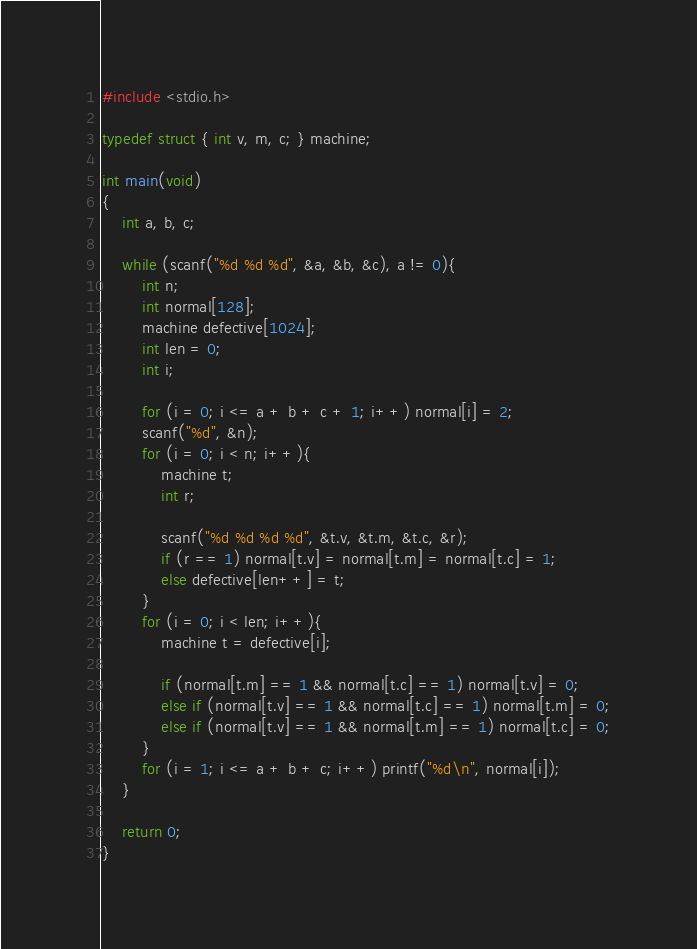Convert code to text. <code><loc_0><loc_0><loc_500><loc_500><_C_>#include <stdio.h>

typedef struct { int v, m, c; } machine;

int main(void)
{
	int a, b, c;
	
	while (scanf("%d %d %d", &a, &b, &c), a != 0){
		int n;
		int normal[128];
		machine defective[1024];
		int len = 0;
		int i;
		
		for (i = 0; i <= a + b + c + 1; i++) normal[i] = 2;
		scanf("%d", &n);
		for (i = 0; i < n; i++){
			machine t;
			int r;
			
			scanf("%d %d %d %d", &t.v, &t.m, &t.c, &r);
			if (r == 1) normal[t.v] = normal[t.m] = normal[t.c] = 1;
			else defective[len++] = t;
		}
		for (i = 0; i < len; i++){
			machine t = defective[i];
			
			if (normal[t.m] == 1 && normal[t.c] == 1) normal[t.v] = 0;
			else if (normal[t.v] == 1 && normal[t.c] == 1) normal[t.m] = 0;
			else if (normal[t.v] == 1 && normal[t.m] == 1) normal[t.c] = 0;
		}
		for (i = 1; i <= a + b + c; i++) printf("%d\n", normal[i]);
	}
	
	return 0;
}</code> 